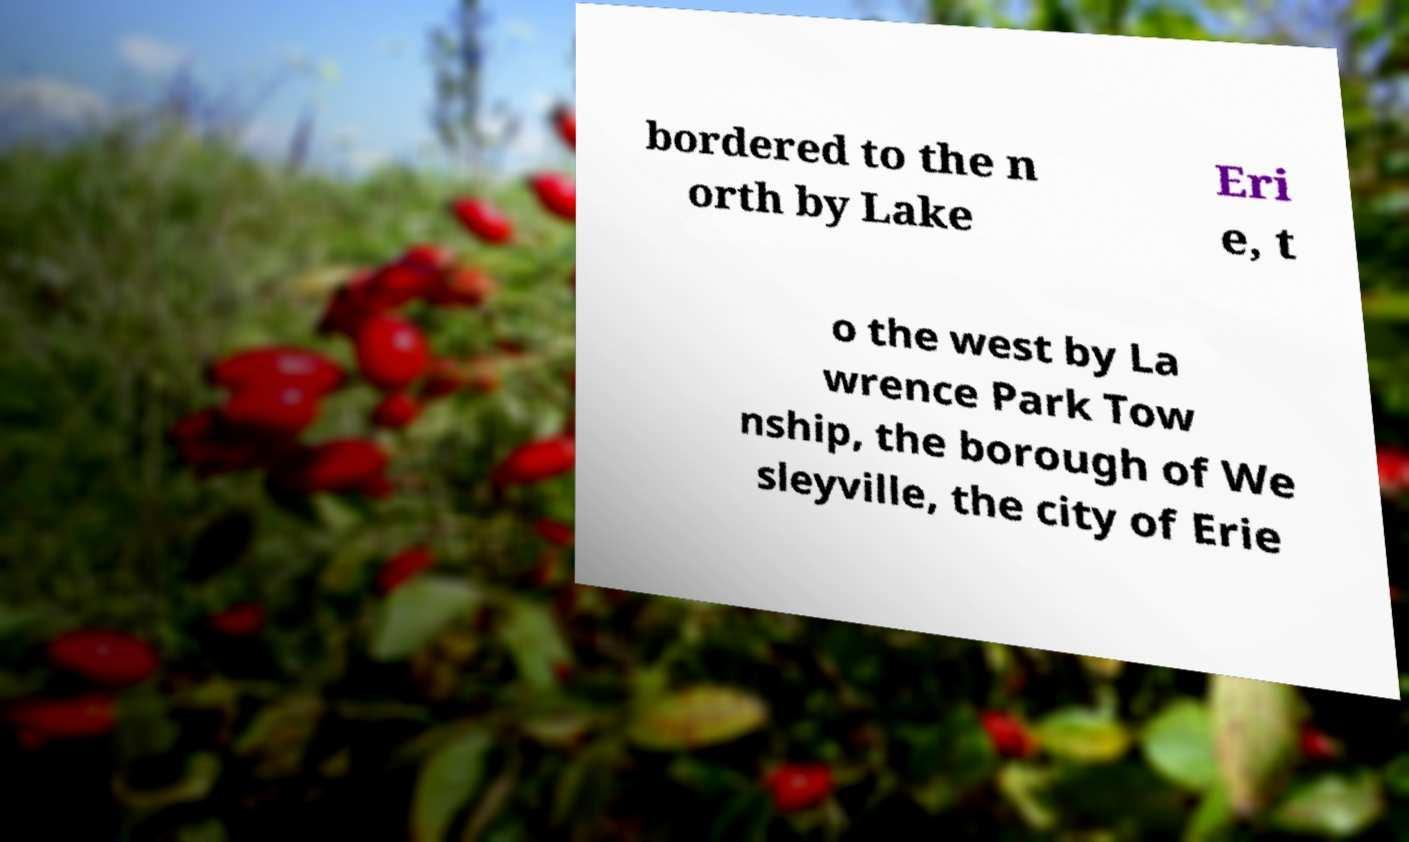I need the written content from this picture converted into text. Can you do that? bordered to the n orth by Lake Eri e, t o the west by La wrence Park Tow nship, the borough of We sleyville, the city of Erie 